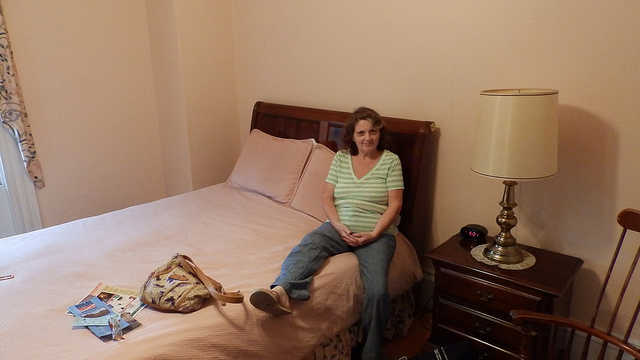Where are the red net stockings? There are no red net stockings visible in the image. The scene only shows a woman sitting on a bed without any such item in sight. 